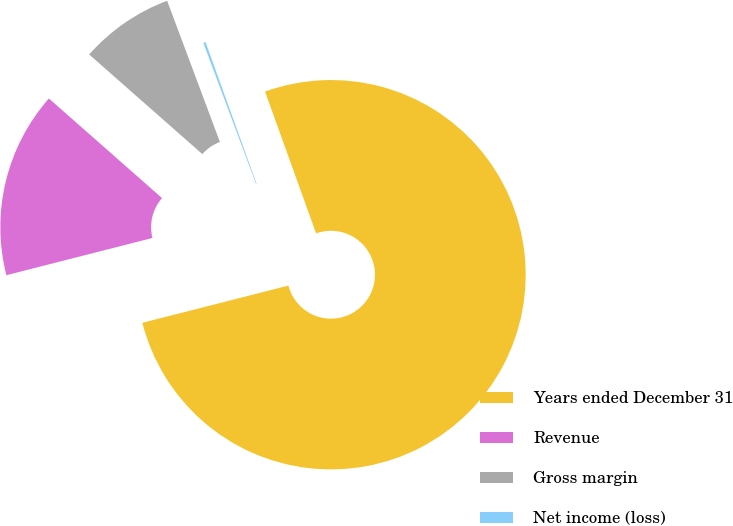Convert chart to OTSL. <chart><loc_0><loc_0><loc_500><loc_500><pie_chart><fcel>Years ended December 31<fcel>Revenue<fcel>Gross margin<fcel>Net income (loss)<nl><fcel>76.53%<fcel>15.46%<fcel>7.82%<fcel>0.19%<nl></chart> 